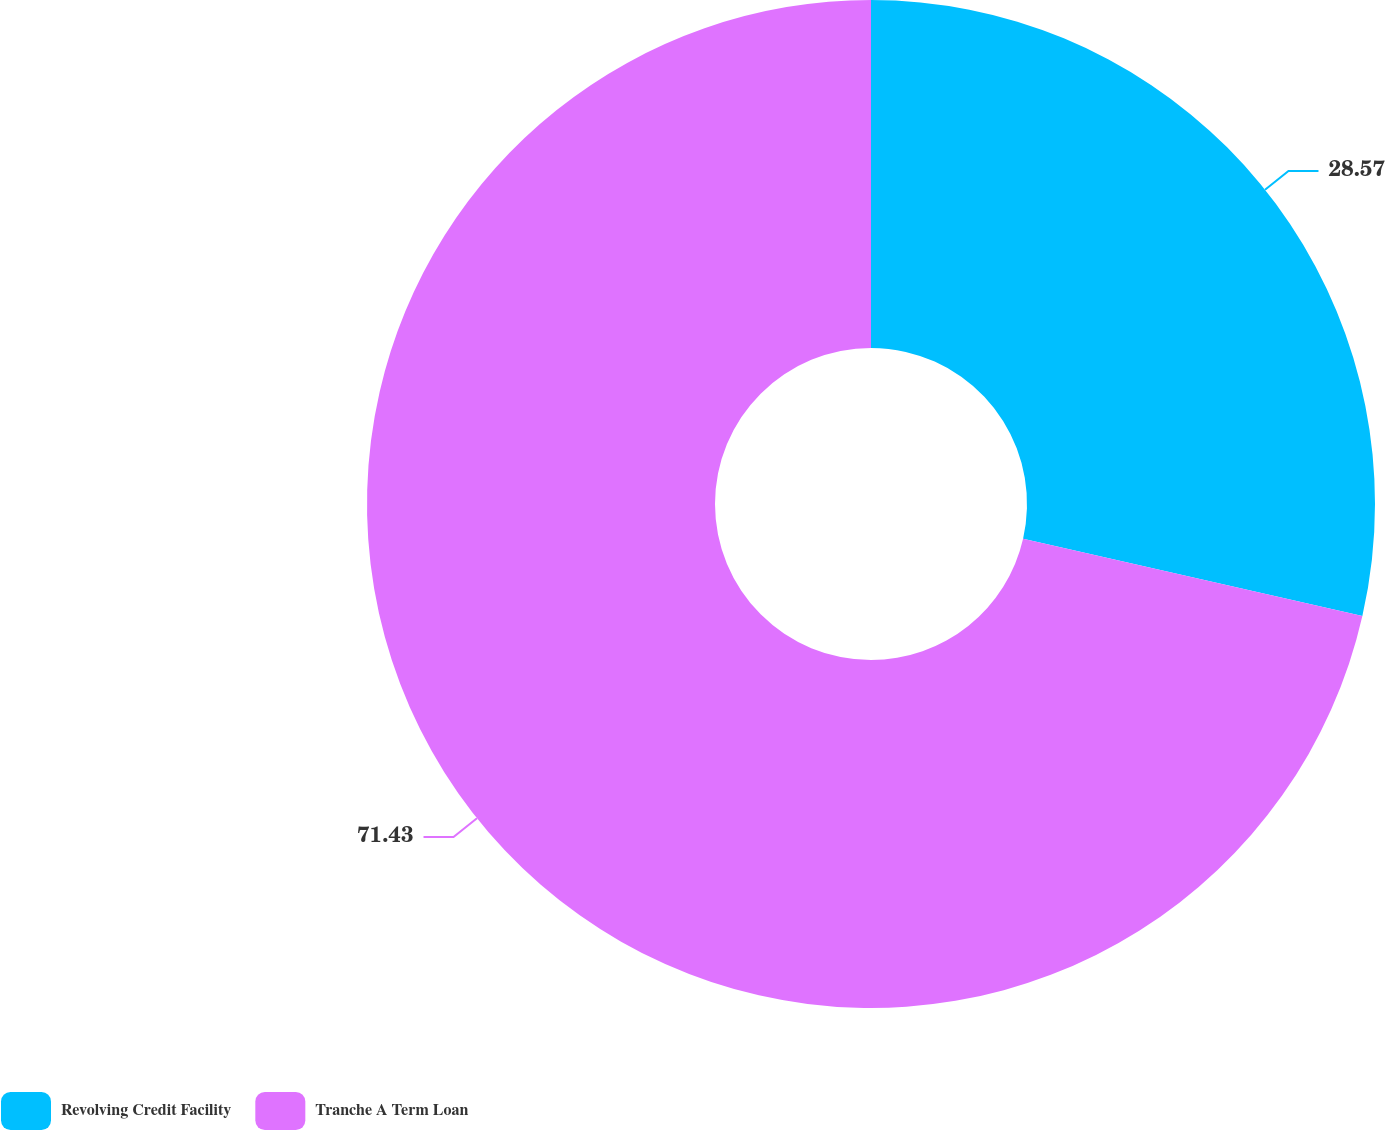Convert chart to OTSL. <chart><loc_0><loc_0><loc_500><loc_500><pie_chart><fcel>Revolving Credit Facility<fcel>Tranche A Term Loan<nl><fcel>28.57%<fcel>71.43%<nl></chart> 